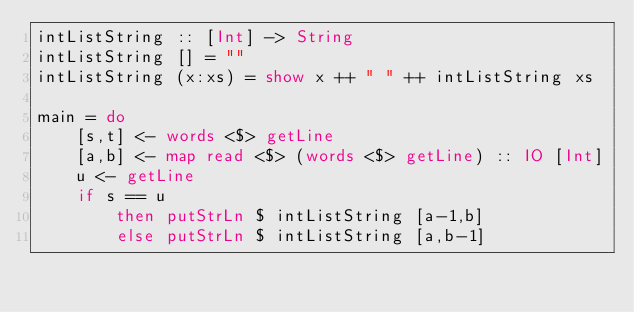<code> <loc_0><loc_0><loc_500><loc_500><_Haskell_>intListString :: [Int] -> String
intListString [] = ""
intListString (x:xs) = show x ++ " " ++ intListString xs

main = do
    [s,t] <- words <$> getLine
    [a,b] <- map read <$> (words <$> getLine) :: IO [Int]
    u <- getLine
    if s == u
        then putStrLn $ intListString [a-1,b]
        else putStrLn $ intListString [a,b-1]

</code> 